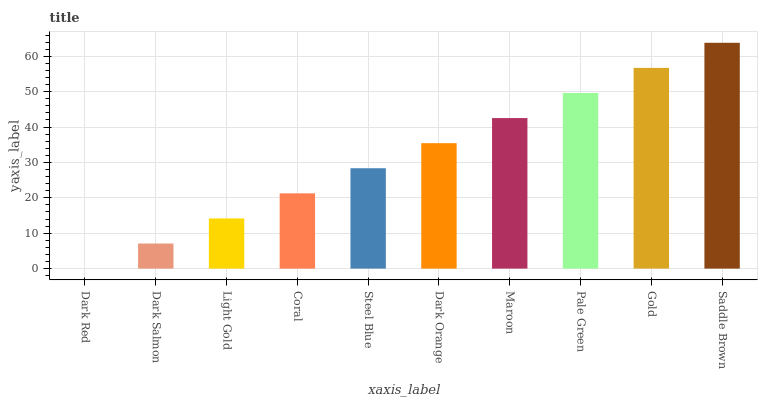Is Dark Red the minimum?
Answer yes or no. Yes. Is Saddle Brown the maximum?
Answer yes or no. Yes. Is Dark Salmon the minimum?
Answer yes or no. No. Is Dark Salmon the maximum?
Answer yes or no. No. Is Dark Salmon greater than Dark Red?
Answer yes or no. Yes. Is Dark Red less than Dark Salmon?
Answer yes or no. Yes. Is Dark Red greater than Dark Salmon?
Answer yes or no. No. Is Dark Salmon less than Dark Red?
Answer yes or no. No. Is Dark Orange the high median?
Answer yes or no. Yes. Is Steel Blue the low median?
Answer yes or no. Yes. Is Pale Green the high median?
Answer yes or no. No. Is Dark Orange the low median?
Answer yes or no. No. 